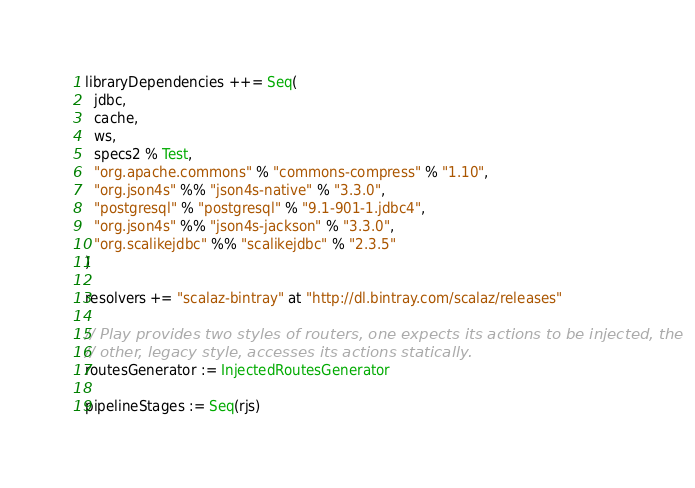Convert code to text. <code><loc_0><loc_0><loc_500><loc_500><_Scala_>
libraryDependencies ++= Seq(
  jdbc,
  cache,
  ws,
  specs2 % Test,
  "org.apache.commons" % "commons-compress" % "1.10",
  "org.json4s" %% "json4s-native" % "3.3.0",
  "postgresql" % "postgresql" % "9.1-901-1.jdbc4",
  "org.json4s" %% "json4s-jackson" % "3.3.0",
  "org.scalikejdbc" %% "scalikejdbc" % "2.3.5"
)

resolvers += "scalaz-bintray" at "http://dl.bintray.com/scalaz/releases"

// Play provides two styles of routers, one expects its actions to be injected, the
// other, legacy style, accesses its actions statically.
routesGenerator := InjectedRoutesGenerator

pipelineStages := Seq(rjs)
</code> 